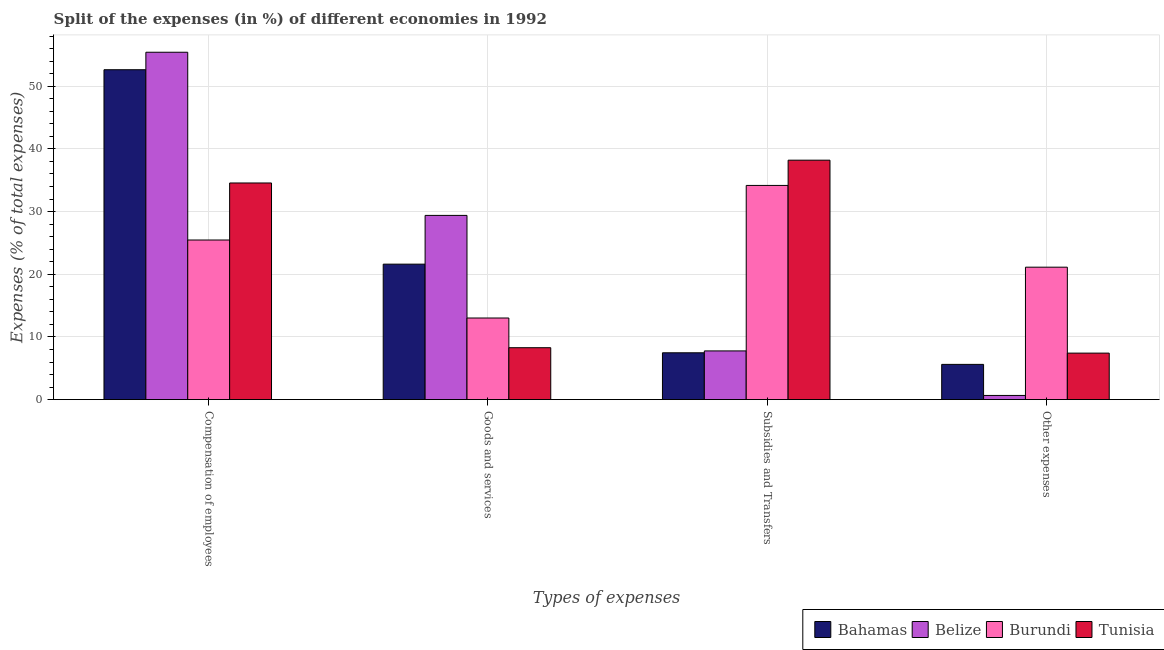How many different coloured bars are there?
Offer a terse response. 4. Are the number of bars per tick equal to the number of legend labels?
Give a very brief answer. Yes. Are the number of bars on each tick of the X-axis equal?
Your answer should be very brief. Yes. How many bars are there on the 2nd tick from the left?
Your response must be concise. 4. How many bars are there on the 4th tick from the right?
Your answer should be very brief. 4. What is the label of the 1st group of bars from the left?
Give a very brief answer. Compensation of employees. What is the percentage of amount spent on other expenses in Belize?
Keep it short and to the point. 0.66. Across all countries, what is the maximum percentage of amount spent on compensation of employees?
Ensure brevity in your answer.  55.42. Across all countries, what is the minimum percentage of amount spent on subsidies?
Your answer should be very brief. 7.47. In which country was the percentage of amount spent on subsidies maximum?
Keep it short and to the point. Tunisia. In which country was the percentage of amount spent on other expenses minimum?
Keep it short and to the point. Belize. What is the total percentage of amount spent on compensation of employees in the graph?
Make the answer very short. 168.08. What is the difference between the percentage of amount spent on subsidies in Tunisia and that in Bahamas?
Provide a succinct answer. 30.73. What is the difference between the percentage of amount spent on other expenses in Belize and the percentage of amount spent on subsidies in Burundi?
Ensure brevity in your answer.  -33.51. What is the average percentage of amount spent on goods and services per country?
Ensure brevity in your answer.  18.08. What is the difference between the percentage of amount spent on goods and services and percentage of amount spent on subsidies in Tunisia?
Your response must be concise. -29.92. What is the ratio of the percentage of amount spent on subsidies in Burundi to that in Belize?
Offer a very short reply. 4.4. Is the percentage of amount spent on compensation of employees in Belize less than that in Bahamas?
Offer a very short reply. No. Is the difference between the percentage of amount spent on subsidies in Tunisia and Burundi greater than the difference between the percentage of amount spent on compensation of employees in Tunisia and Burundi?
Ensure brevity in your answer.  No. What is the difference between the highest and the second highest percentage of amount spent on subsidies?
Your response must be concise. 4.03. What is the difference between the highest and the lowest percentage of amount spent on subsidies?
Your answer should be very brief. 30.73. In how many countries, is the percentage of amount spent on other expenses greater than the average percentage of amount spent on other expenses taken over all countries?
Ensure brevity in your answer.  1. Is the sum of the percentage of amount spent on other expenses in Burundi and Bahamas greater than the maximum percentage of amount spent on goods and services across all countries?
Give a very brief answer. No. What does the 4th bar from the left in Compensation of employees represents?
Provide a succinct answer. Tunisia. What does the 3rd bar from the right in Compensation of employees represents?
Give a very brief answer. Belize. How many bars are there?
Give a very brief answer. 16. Are all the bars in the graph horizontal?
Provide a short and direct response. No. How many countries are there in the graph?
Your answer should be very brief. 4. What is the title of the graph?
Ensure brevity in your answer.  Split of the expenses (in %) of different economies in 1992. What is the label or title of the X-axis?
Make the answer very short. Types of expenses. What is the label or title of the Y-axis?
Give a very brief answer. Expenses (% of total expenses). What is the Expenses (% of total expenses) in Bahamas in Compensation of employees?
Keep it short and to the point. 52.63. What is the Expenses (% of total expenses) in Belize in Compensation of employees?
Offer a terse response. 55.42. What is the Expenses (% of total expenses) in Burundi in Compensation of employees?
Give a very brief answer. 25.46. What is the Expenses (% of total expenses) in Tunisia in Compensation of employees?
Offer a very short reply. 34.56. What is the Expenses (% of total expenses) in Bahamas in Goods and services?
Your answer should be very brief. 21.61. What is the Expenses (% of total expenses) in Belize in Goods and services?
Your response must be concise. 29.39. What is the Expenses (% of total expenses) of Burundi in Goods and services?
Make the answer very short. 13.02. What is the Expenses (% of total expenses) of Tunisia in Goods and services?
Your response must be concise. 8.28. What is the Expenses (% of total expenses) of Bahamas in Subsidies and Transfers?
Make the answer very short. 7.47. What is the Expenses (% of total expenses) of Belize in Subsidies and Transfers?
Your answer should be very brief. 7.77. What is the Expenses (% of total expenses) in Burundi in Subsidies and Transfers?
Your answer should be compact. 34.17. What is the Expenses (% of total expenses) of Tunisia in Subsidies and Transfers?
Keep it short and to the point. 38.2. What is the Expenses (% of total expenses) of Bahamas in Other expenses?
Ensure brevity in your answer.  5.62. What is the Expenses (% of total expenses) in Belize in Other expenses?
Your response must be concise. 0.66. What is the Expenses (% of total expenses) in Burundi in Other expenses?
Provide a succinct answer. 21.13. What is the Expenses (% of total expenses) in Tunisia in Other expenses?
Your response must be concise. 7.42. Across all Types of expenses, what is the maximum Expenses (% of total expenses) of Bahamas?
Provide a short and direct response. 52.63. Across all Types of expenses, what is the maximum Expenses (% of total expenses) in Belize?
Your answer should be compact. 55.42. Across all Types of expenses, what is the maximum Expenses (% of total expenses) in Burundi?
Provide a succinct answer. 34.17. Across all Types of expenses, what is the maximum Expenses (% of total expenses) in Tunisia?
Your answer should be compact. 38.2. Across all Types of expenses, what is the minimum Expenses (% of total expenses) in Bahamas?
Your answer should be compact. 5.62. Across all Types of expenses, what is the minimum Expenses (% of total expenses) in Belize?
Provide a succinct answer. 0.66. Across all Types of expenses, what is the minimum Expenses (% of total expenses) of Burundi?
Give a very brief answer. 13.02. Across all Types of expenses, what is the minimum Expenses (% of total expenses) in Tunisia?
Your answer should be very brief. 7.42. What is the total Expenses (% of total expenses) of Bahamas in the graph?
Provide a succinct answer. 87.34. What is the total Expenses (% of total expenses) of Belize in the graph?
Give a very brief answer. 93.24. What is the total Expenses (% of total expenses) in Burundi in the graph?
Keep it short and to the point. 93.78. What is the total Expenses (% of total expenses) of Tunisia in the graph?
Ensure brevity in your answer.  88.46. What is the difference between the Expenses (% of total expenses) in Bahamas in Compensation of employees and that in Goods and services?
Provide a short and direct response. 31.02. What is the difference between the Expenses (% of total expenses) in Belize in Compensation of employees and that in Goods and services?
Provide a succinct answer. 26.03. What is the difference between the Expenses (% of total expenses) of Burundi in Compensation of employees and that in Goods and services?
Offer a terse response. 12.44. What is the difference between the Expenses (% of total expenses) in Tunisia in Compensation of employees and that in Goods and services?
Your answer should be compact. 26.28. What is the difference between the Expenses (% of total expenses) of Bahamas in Compensation of employees and that in Subsidies and Transfers?
Ensure brevity in your answer.  45.16. What is the difference between the Expenses (% of total expenses) of Belize in Compensation of employees and that in Subsidies and Transfers?
Ensure brevity in your answer.  47.65. What is the difference between the Expenses (% of total expenses) of Burundi in Compensation of employees and that in Subsidies and Transfers?
Offer a terse response. -8.71. What is the difference between the Expenses (% of total expenses) in Tunisia in Compensation of employees and that in Subsidies and Transfers?
Keep it short and to the point. -3.64. What is the difference between the Expenses (% of total expenses) of Bahamas in Compensation of employees and that in Other expenses?
Keep it short and to the point. 47.01. What is the difference between the Expenses (% of total expenses) of Belize in Compensation of employees and that in Other expenses?
Make the answer very short. 54.76. What is the difference between the Expenses (% of total expenses) of Burundi in Compensation of employees and that in Other expenses?
Offer a terse response. 4.33. What is the difference between the Expenses (% of total expenses) of Tunisia in Compensation of employees and that in Other expenses?
Provide a short and direct response. 27.15. What is the difference between the Expenses (% of total expenses) in Bahamas in Goods and services and that in Subsidies and Transfers?
Provide a short and direct response. 14.14. What is the difference between the Expenses (% of total expenses) in Belize in Goods and services and that in Subsidies and Transfers?
Keep it short and to the point. 21.62. What is the difference between the Expenses (% of total expenses) of Burundi in Goods and services and that in Subsidies and Transfers?
Your answer should be very brief. -21.15. What is the difference between the Expenses (% of total expenses) of Tunisia in Goods and services and that in Subsidies and Transfers?
Your response must be concise. -29.92. What is the difference between the Expenses (% of total expenses) of Bahamas in Goods and services and that in Other expenses?
Your response must be concise. 15.99. What is the difference between the Expenses (% of total expenses) of Belize in Goods and services and that in Other expenses?
Your answer should be compact. 28.73. What is the difference between the Expenses (% of total expenses) in Burundi in Goods and services and that in Other expenses?
Offer a terse response. -8.11. What is the difference between the Expenses (% of total expenses) of Tunisia in Goods and services and that in Other expenses?
Provide a succinct answer. 0.86. What is the difference between the Expenses (% of total expenses) of Bahamas in Subsidies and Transfers and that in Other expenses?
Provide a succinct answer. 1.85. What is the difference between the Expenses (% of total expenses) in Belize in Subsidies and Transfers and that in Other expenses?
Keep it short and to the point. 7.1. What is the difference between the Expenses (% of total expenses) in Burundi in Subsidies and Transfers and that in Other expenses?
Provide a succinct answer. 13.04. What is the difference between the Expenses (% of total expenses) in Tunisia in Subsidies and Transfers and that in Other expenses?
Offer a terse response. 30.78. What is the difference between the Expenses (% of total expenses) of Bahamas in Compensation of employees and the Expenses (% of total expenses) of Belize in Goods and services?
Offer a very short reply. 23.24. What is the difference between the Expenses (% of total expenses) in Bahamas in Compensation of employees and the Expenses (% of total expenses) in Burundi in Goods and services?
Your response must be concise. 39.61. What is the difference between the Expenses (% of total expenses) in Bahamas in Compensation of employees and the Expenses (% of total expenses) in Tunisia in Goods and services?
Provide a succinct answer. 44.35. What is the difference between the Expenses (% of total expenses) of Belize in Compensation of employees and the Expenses (% of total expenses) of Burundi in Goods and services?
Give a very brief answer. 42.4. What is the difference between the Expenses (% of total expenses) in Belize in Compensation of employees and the Expenses (% of total expenses) in Tunisia in Goods and services?
Offer a terse response. 47.14. What is the difference between the Expenses (% of total expenses) of Burundi in Compensation of employees and the Expenses (% of total expenses) of Tunisia in Goods and services?
Provide a succinct answer. 17.18. What is the difference between the Expenses (% of total expenses) of Bahamas in Compensation of employees and the Expenses (% of total expenses) of Belize in Subsidies and Transfers?
Provide a succinct answer. 44.86. What is the difference between the Expenses (% of total expenses) of Bahamas in Compensation of employees and the Expenses (% of total expenses) of Burundi in Subsidies and Transfers?
Give a very brief answer. 18.46. What is the difference between the Expenses (% of total expenses) in Bahamas in Compensation of employees and the Expenses (% of total expenses) in Tunisia in Subsidies and Transfers?
Provide a succinct answer. 14.43. What is the difference between the Expenses (% of total expenses) in Belize in Compensation of employees and the Expenses (% of total expenses) in Burundi in Subsidies and Transfers?
Provide a succinct answer. 21.25. What is the difference between the Expenses (% of total expenses) in Belize in Compensation of employees and the Expenses (% of total expenses) in Tunisia in Subsidies and Transfers?
Provide a short and direct response. 17.22. What is the difference between the Expenses (% of total expenses) in Burundi in Compensation of employees and the Expenses (% of total expenses) in Tunisia in Subsidies and Transfers?
Your answer should be compact. -12.74. What is the difference between the Expenses (% of total expenses) of Bahamas in Compensation of employees and the Expenses (% of total expenses) of Belize in Other expenses?
Give a very brief answer. 51.97. What is the difference between the Expenses (% of total expenses) of Bahamas in Compensation of employees and the Expenses (% of total expenses) of Burundi in Other expenses?
Your answer should be very brief. 31.5. What is the difference between the Expenses (% of total expenses) in Bahamas in Compensation of employees and the Expenses (% of total expenses) in Tunisia in Other expenses?
Keep it short and to the point. 45.21. What is the difference between the Expenses (% of total expenses) in Belize in Compensation of employees and the Expenses (% of total expenses) in Burundi in Other expenses?
Your answer should be very brief. 34.29. What is the difference between the Expenses (% of total expenses) of Belize in Compensation of employees and the Expenses (% of total expenses) of Tunisia in Other expenses?
Keep it short and to the point. 48. What is the difference between the Expenses (% of total expenses) of Burundi in Compensation of employees and the Expenses (% of total expenses) of Tunisia in Other expenses?
Provide a succinct answer. 18.05. What is the difference between the Expenses (% of total expenses) in Bahamas in Goods and services and the Expenses (% of total expenses) in Belize in Subsidies and Transfers?
Offer a terse response. 13.84. What is the difference between the Expenses (% of total expenses) of Bahamas in Goods and services and the Expenses (% of total expenses) of Burundi in Subsidies and Transfers?
Your response must be concise. -12.56. What is the difference between the Expenses (% of total expenses) of Bahamas in Goods and services and the Expenses (% of total expenses) of Tunisia in Subsidies and Transfers?
Offer a very short reply. -16.59. What is the difference between the Expenses (% of total expenses) in Belize in Goods and services and the Expenses (% of total expenses) in Burundi in Subsidies and Transfers?
Offer a terse response. -4.78. What is the difference between the Expenses (% of total expenses) of Belize in Goods and services and the Expenses (% of total expenses) of Tunisia in Subsidies and Transfers?
Give a very brief answer. -8.81. What is the difference between the Expenses (% of total expenses) of Burundi in Goods and services and the Expenses (% of total expenses) of Tunisia in Subsidies and Transfers?
Offer a terse response. -25.18. What is the difference between the Expenses (% of total expenses) of Bahamas in Goods and services and the Expenses (% of total expenses) of Belize in Other expenses?
Keep it short and to the point. 20.95. What is the difference between the Expenses (% of total expenses) of Bahamas in Goods and services and the Expenses (% of total expenses) of Burundi in Other expenses?
Your answer should be compact. 0.48. What is the difference between the Expenses (% of total expenses) in Bahamas in Goods and services and the Expenses (% of total expenses) in Tunisia in Other expenses?
Provide a succinct answer. 14.19. What is the difference between the Expenses (% of total expenses) in Belize in Goods and services and the Expenses (% of total expenses) in Burundi in Other expenses?
Offer a very short reply. 8.26. What is the difference between the Expenses (% of total expenses) in Belize in Goods and services and the Expenses (% of total expenses) in Tunisia in Other expenses?
Provide a succinct answer. 21.97. What is the difference between the Expenses (% of total expenses) of Burundi in Goods and services and the Expenses (% of total expenses) of Tunisia in Other expenses?
Your answer should be very brief. 5.6. What is the difference between the Expenses (% of total expenses) in Bahamas in Subsidies and Transfers and the Expenses (% of total expenses) in Belize in Other expenses?
Give a very brief answer. 6.81. What is the difference between the Expenses (% of total expenses) in Bahamas in Subsidies and Transfers and the Expenses (% of total expenses) in Burundi in Other expenses?
Give a very brief answer. -13.66. What is the difference between the Expenses (% of total expenses) in Bahamas in Subsidies and Transfers and the Expenses (% of total expenses) in Tunisia in Other expenses?
Offer a terse response. 0.05. What is the difference between the Expenses (% of total expenses) of Belize in Subsidies and Transfers and the Expenses (% of total expenses) of Burundi in Other expenses?
Your answer should be very brief. -13.36. What is the difference between the Expenses (% of total expenses) in Belize in Subsidies and Transfers and the Expenses (% of total expenses) in Tunisia in Other expenses?
Keep it short and to the point. 0.35. What is the difference between the Expenses (% of total expenses) of Burundi in Subsidies and Transfers and the Expenses (% of total expenses) of Tunisia in Other expenses?
Keep it short and to the point. 26.75. What is the average Expenses (% of total expenses) of Bahamas per Types of expenses?
Offer a terse response. 21.83. What is the average Expenses (% of total expenses) in Belize per Types of expenses?
Provide a short and direct response. 23.31. What is the average Expenses (% of total expenses) in Burundi per Types of expenses?
Offer a very short reply. 23.45. What is the average Expenses (% of total expenses) in Tunisia per Types of expenses?
Keep it short and to the point. 22.12. What is the difference between the Expenses (% of total expenses) of Bahamas and Expenses (% of total expenses) of Belize in Compensation of employees?
Provide a short and direct response. -2.79. What is the difference between the Expenses (% of total expenses) of Bahamas and Expenses (% of total expenses) of Burundi in Compensation of employees?
Your response must be concise. 27.17. What is the difference between the Expenses (% of total expenses) in Bahamas and Expenses (% of total expenses) in Tunisia in Compensation of employees?
Your response must be concise. 18.07. What is the difference between the Expenses (% of total expenses) of Belize and Expenses (% of total expenses) of Burundi in Compensation of employees?
Provide a short and direct response. 29.96. What is the difference between the Expenses (% of total expenses) of Belize and Expenses (% of total expenses) of Tunisia in Compensation of employees?
Offer a terse response. 20.86. What is the difference between the Expenses (% of total expenses) of Burundi and Expenses (% of total expenses) of Tunisia in Compensation of employees?
Provide a short and direct response. -9.1. What is the difference between the Expenses (% of total expenses) of Bahamas and Expenses (% of total expenses) of Belize in Goods and services?
Keep it short and to the point. -7.78. What is the difference between the Expenses (% of total expenses) of Bahamas and Expenses (% of total expenses) of Burundi in Goods and services?
Offer a very short reply. 8.59. What is the difference between the Expenses (% of total expenses) in Bahamas and Expenses (% of total expenses) in Tunisia in Goods and services?
Provide a short and direct response. 13.33. What is the difference between the Expenses (% of total expenses) of Belize and Expenses (% of total expenses) of Burundi in Goods and services?
Your answer should be compact. 16.37. What is the difference between the Expenses (% of total expenses) of Belize and Expenses (% of total expenses) of Tunisia in Goods and services?
Your response must be concise. 21.11. What is the difference between the Expenses (% of total expenses) of Burundi and Expenses (% of total expenses) of Tunisia in Goods and services?
Provide a short and direct response. 4.74. What is the difference between the Expenses (% of total expenses) in Bahamas and Expenses (% of total expenses) in Belize in Subsidies and Transfers?
Keep it short and to the point. -0.3. What is the difference between the Expenses (% of total expenses) of Bahamas and Expenses (% of total expenses) of Burundi in Subsidies and Transfers?
Offer a very short reply. -26.7. What is the difference between the Expenses (% of total expenses) in Bahamas and Expenses (% of total expenses) in Tunisia in Subsidies and Transfers?
Give a very brief answer. -30.73. What is the difference between the Expenses (% of total expenses) of Belize and Expenses (% of total expenses) of Burundi in Subsidies and Transfers?
Offer a very short reply. -26.4. What is the difference between the Expenses (% of total expenses) in Belize and Expenses (% of total expenses) in Tunisia in Subsidies and Transfers?
Your answer should be very brief. -30.43. What is the difference between the Expenses (% of total expenses) in Burundi and Expenses (% of total expenses) in Tunisia in Subsidies and Transfers?
Your answer should be compact. -4.03. What is the difference between the Expenses (% of total expenses) in Bahamas and Expenses (% of total expenses) in Belize in Other expenses?
Your answer should be very brief. 4.96. What is the difference between the Expenses (% of total expenses) in Bahamas and Expenses (% of total expenses) in Burundi in Other expenses?
Offer a terse response. -15.51. What is the difference between the Expenses (% of total expenses) in Bahamas and Expenses (% of total expenses) in Tunisia in Other expenses?
Your answer should be compact. -1.8. What is the difference between the Expenses (% of total expenses) of Belize and Expenses (% of total expenses) of Burundi in Other expenses?
Give a very brief answer. -20.47. What is the difference between the Expenses (% of total expenses) of Belize and Expenses (% of total expenses) of Tunisia in Other expenses?
Your answer should be very brief. -6.75. What is the difference between the Expenses (% of total expenses) of Burundi and Expenses (% of total expenses) of Tunisia in Other expenses?
Give a very brief answer. 13.71. What is the ratio of the Expenses (% of total expenses) in Bahamas in Compensation of employees to that in Goods and services?
Offer a very short reply. 2.44. What is the ratio of the Expenses (% of total expenses) of Belize in Compensation of employees to that in Goods and services?
Offer a very short reply. 1.89. What is the ratio of the Expenses (% of total expenses) in Burundi in Compensation of employees to that in Goods and services?
Ensure brevity in your answer.  1.96. What is the ratio of the Expenses (% of total expenses) of Tunisia in Compensation of employees to that in Goods and services?
Your answer should be very brief. 4.17. What is the ratio of the Expenses (% of total expenses) of Bahamas in Compensation of employees to that in Subsidies and Transfers?
Keep it short and to the point. 7.05. What is the ratio of the Expenses (% of total expenses) of Belize in Compensation of employees to that in Subsidies and Transfers?
Ensure brevity in your answer.  7.13. What is the ratio of the Expenses (% of total expenses) in Burundi in Compensation of employees to that in Subsidies and Transfers?
Your answer should be compact. 0.75. What is the ratio of the Expenses (% of total expenses) of Tunisia in Compensation of employees to that in Subsidies and Transfers?
Make the answer very short. 0.9. What is the ratio of the Expenses (% of total expenses) in Bahamas in Compensation of employees to that in Other expenses?
Provide a succinct answer. 9.36. What is the ratio of the Expenses (% of total expenses) of Belize in Compensation of employees to that in Other expenses?
Give a very brief answer. 83.49. What is the ratio of the Expenses (% of total expenses) of Burundi in Compensation of employees to that in Other expenses?
Keep it short and to the point. 1.21. What is the ratio of the Expenses (% of total expenses) of Tunisia in Compensation of employees to that in Other expenses?
Ensure brevity in your answer.  4.66. What is the ratio of the Expenses (% of total expenses) of Bahamas in Goods and services to that in Subsidies and Transfers?
Make the answer very short. 2.89. What is the ratio of the Expenses (% of total expenses) of Belize in Goods and services to that in Subsidies and Transfers?
Offer a terse response. 3.78. What is the ratio of the Expenses (% of total expenses) of Burundi in Goods and services to that in Subsidies and Transfers?
Your response must be concise. 0.38. What is the ratio of the Expenses (% of total expenses) in Tunisia in Goods and services to that in Subsidies and Transfers?
Your response must be concise. 0.22. What is the ratio of the Expenses (% of total expenses) of Bahamas in Goods and services to that in Other expenses?
Your response must be concise. 3.84. What is the ratio of the Expenses (% of total expenses) of Belize in Goods and services to that in Other expenses?
Keep it short and to the point. 44.28. What is the ratio of the Expenses (% of total expenses) in Burundi in Goods and services to that in Other expenses?
Your answer should be very brief. 0.62. What is the ratio of the Expenses (% of total expenses) of Tunisia in Goods and services to that in Other expenses?
Offer a very short reply. 1.12. What is the ratio of the Expenses (% of total expenses) of Bahamas in Subsidies and Transfers to that in Other expenses?
Your response must be concise. 1.33. What is the ratio of the Expenses (% of total expenses) of Belize in Subsidies and Transfers to that in Other expenses?
Your response must be concise. 11.7. What is the ratio of the Expenses (% of total expenses) in Burundi in Subsidies and Transfers to that in Other expenses?
Your answer should be very brief. 1.62. What is the ratio of the Expenses (% of total expenses) in Tunisia in Subsidies and Transfers to that in Other expenses?
Your answer should be compact. 5.15. What is the difference between the highest and the second highest Expenses (% of total expenses) in Bahamas?
Give a very brief answer. 31.02. What is the difference between the highest and the second highest Expenses (% of total expenses) of Belize?
Make the answer very short. 26.03. What is the difference between the highest and the second highest Expenses (% of total expenses) in Burundi?
Give a very brief answer. 8.71. What is the difference between the highest and the second highest Expenses (% of total expenses) of Tunisia?
Provide a succinct answer. 3.64. What is the difference between the highest and the lowest Expenses (% of total expenses) in Bahamas?
Your answer should be very brief. 47.01. What is the difference between the highest and the lowest Expenses (% of total expenses) in Belize?
Provide a short and direct response. 54.76. What is the difference between the highest and the lowest Expenses (% of total expenses) in Burundi?
Provide a short and direct response. 21.15. What is the difference between the highest and the lowest Expenses (% of total expenses) in Tunisia?
Your answer should be very brief. 30.78. 